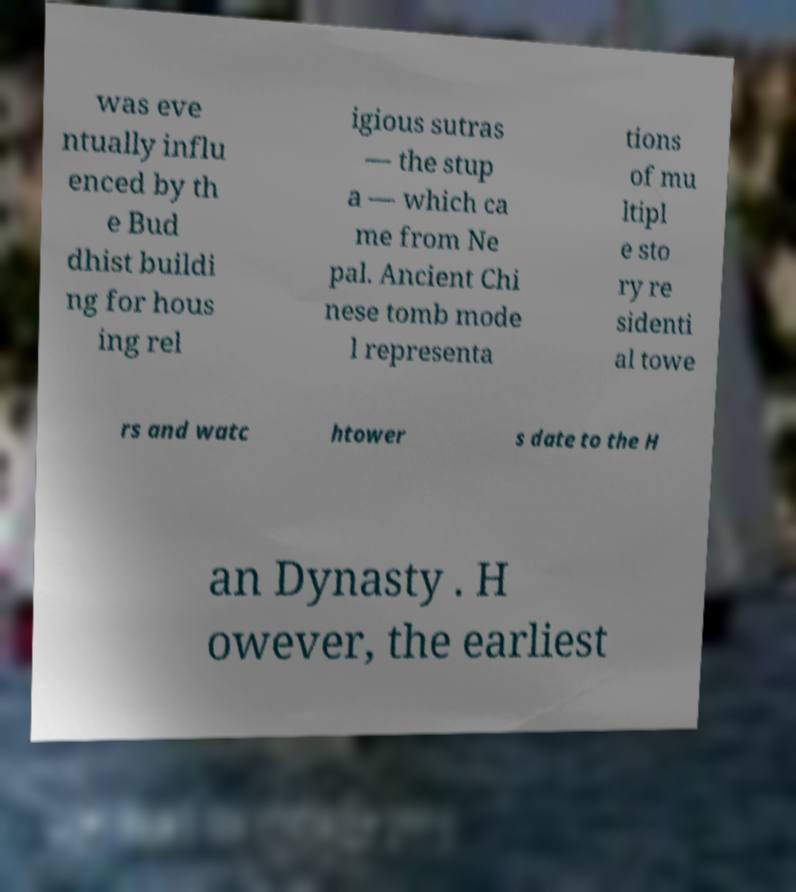I need the written content from this picture converted into text. Can you do that? was eve ntually influ enced by th e Bud dhist buildi ng for hous ing rel igious sutras — the stup a — which ca me from Ne pal. Ancient Chi nese tomb mode l representa tions of mu ltipl e sto ry re sidenti al towe rs and watc htower s date to the H an Dynasty . H owever, the earliest 